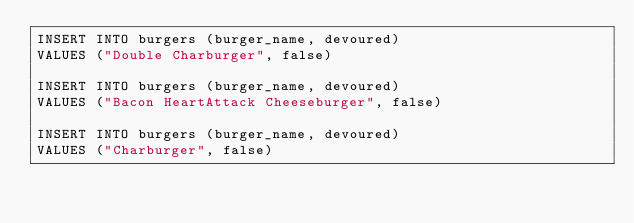<code> <loc_0><loc_0><loc_500><loc_500><_SQL_>INSERT INTO burgers (burger_name, devoured)
VALUES ("Double Charburger", false)

INSERT INTO burgers (burger_name, devoured)
VALUES ("Bacon HeartAttack Cheeseburger", false)

INSERT INTO burgers (burger_name, devoured)
VALUES ("Charburger", false)












</code> 